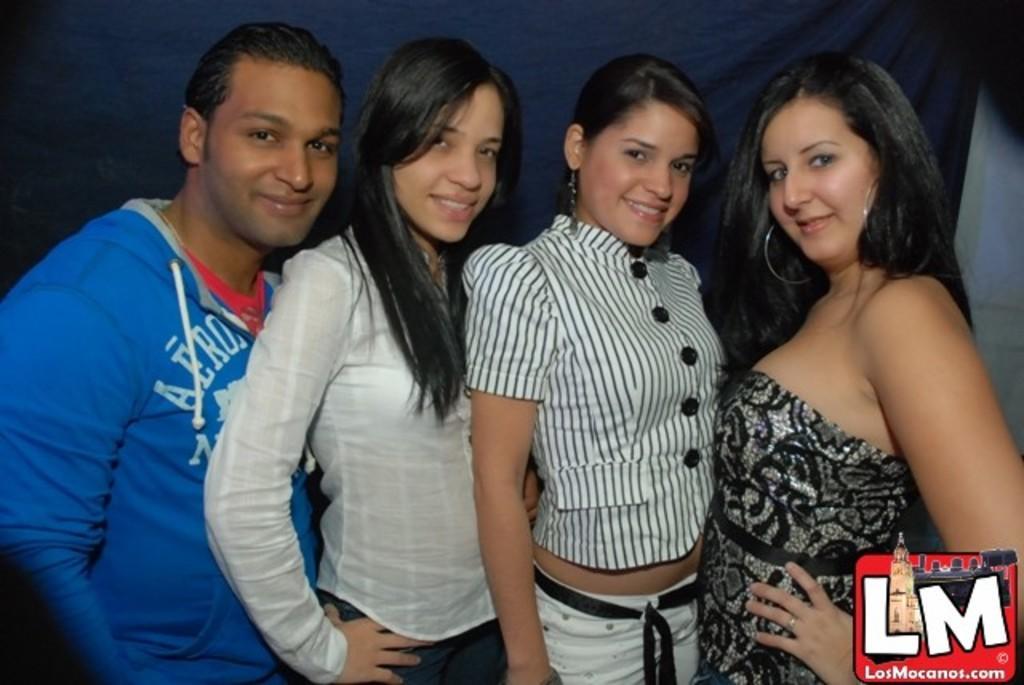In one or two sentences, can you explain what this image depicts? In this image three women and a person are standing. Behind them there is a curtain. Behind it there is a wall. Left side there is a person wearing a jacket. Before him there are three women standing. 